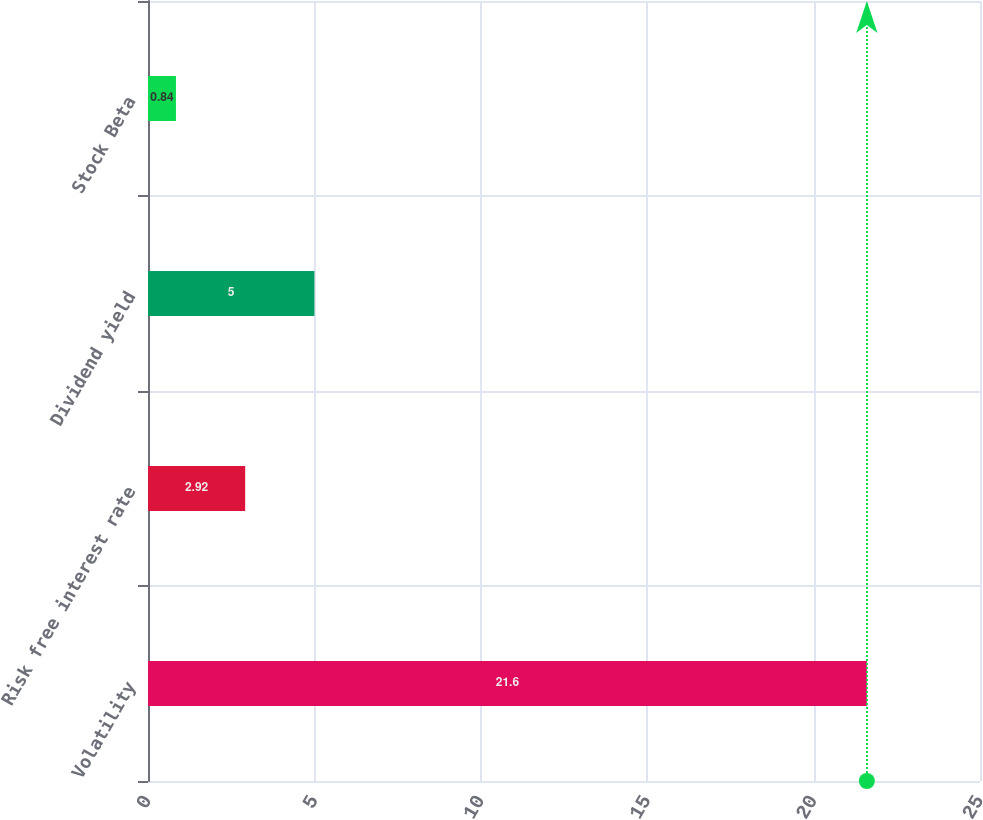<chart> <loc_0><loc_0><loc_500><loc_500><bar_chart><fcel>Volatility<fcel>Risk free interest rate<fcel>Dividend yield<fcel>Stock Beta<nl><fcel>21.6<fcel>2.92<fcel>5<fcel>0.84<nl></chart> 